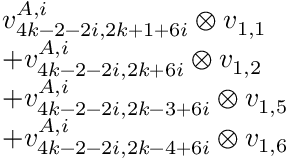<formula> <loc_0><loc_0><loc_500><loc_500>\begin{array} { r l } & { v _ { 4 k - 2 - 2 i , 2 k + 1 + 6 i } ^ { A , i } \otimes v _ { 1 , 1 } } \\ & { + v _ { 4 k - 2 - 2 i , 2 k + 6 i } ^ { A , i } \otimes v _ { 1 , 2 } } \\ & { + v _ { 4 k - 2 - 2 i , 2 k - 3 + 6 i } ^ { A , i } \otimes v _ { 1 , 5 } } \\ & { + v _ { 4 k - 2 - 2 i , 2 k - 4 + 6 i } ^ { A , i } \otimes v _ { 1 , 6 } } \end{array}</formula> 